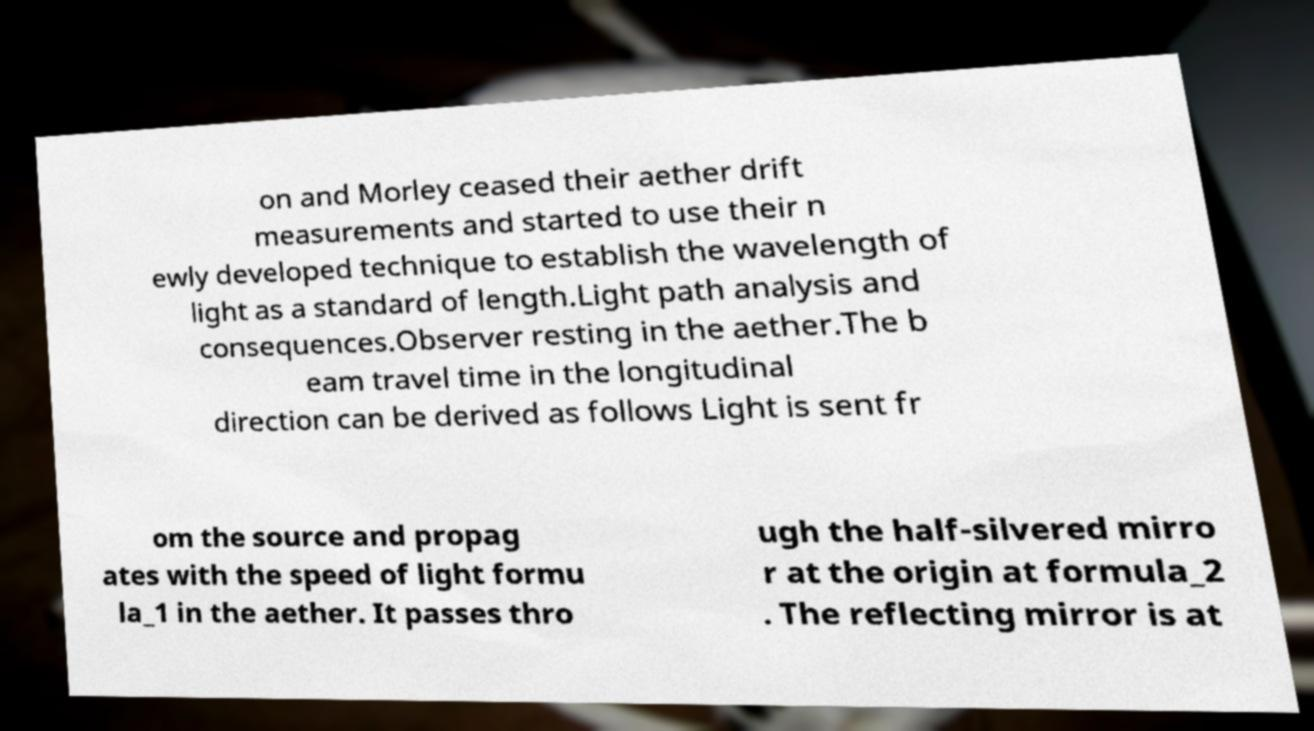Could you extract and type out the text from this image? on and Morley ceased their aether drift measurements and started to use their n ewly developed technique to establish the wavelength of light as a standard of length.Light path analysis and consequences.Observer resting in the aether.The b eam travel time in the longitudinal direction can be derived as follows Light is sent fr om the source and propag ates with the speed of light formu la_1 in the aether. It passes thro ugh the half-silvered mirro r at the origin at formula_2 . The reflecting mirror is at 